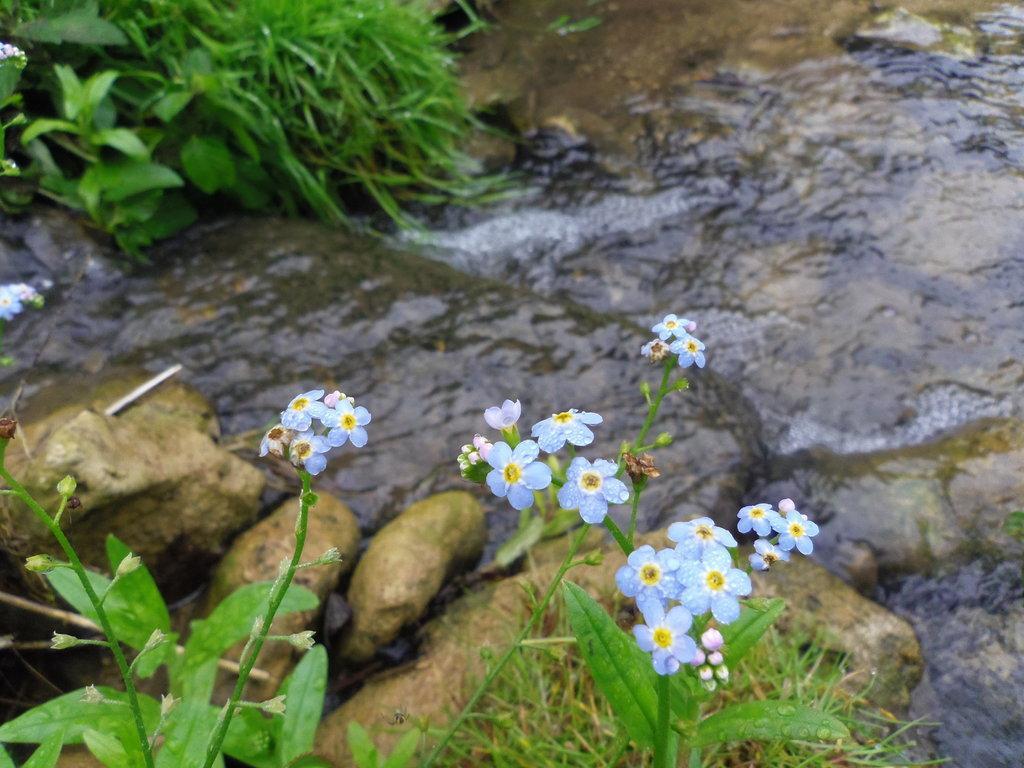Describe this image in one or two sentences. In the foreground of the picture there are plants, flowers, grass and stones. In the center of the picture it is water flowing. At the top left there are plants and grass. 